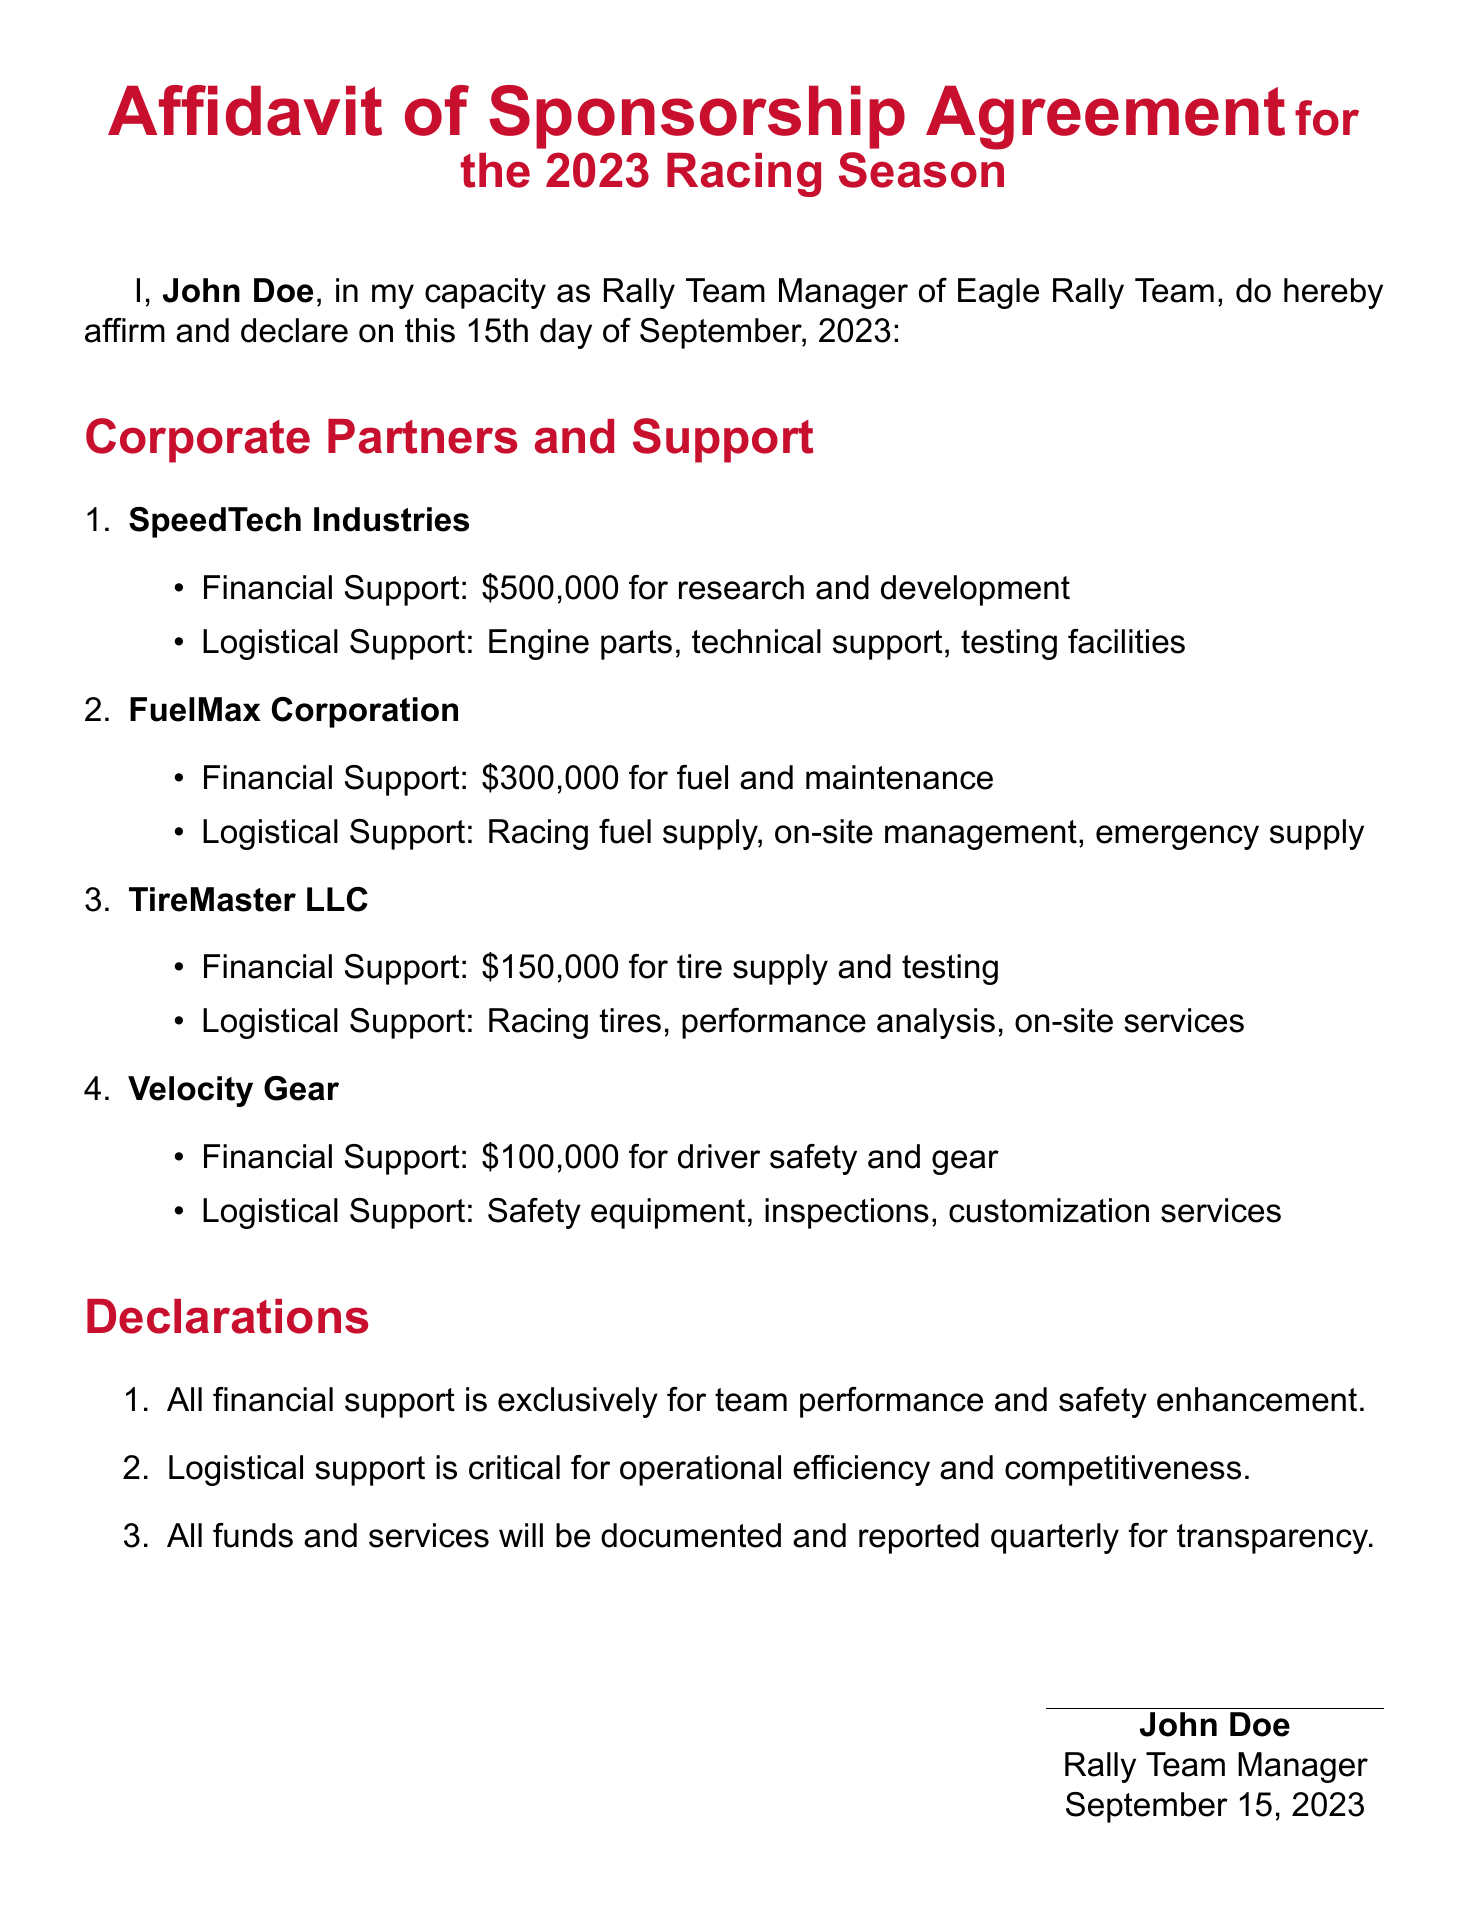What is the name of the Rally Team Manager? The document states the name of the Rally Team Manager as John Doe.
Answer: John Doe What date was the affidavit signed? The affidavit was signed on September 15, 2023, as indicated in the document.
Answer: September 15, 2023 How much financial support does SpeedTech Industries provide? The document specifies that SpeedTech Industries provides financial support of $500,000.
Answer: $500,000 What type of support does TireMaster LLC provide? TireMaster LLC provides racing tires and performance analysis as logistical support.
Answer: Racing tires, performance analysis How many corporate partners are listed in the affidavit? The document enumerates four corporate partners involved in the sponsorship agreement.
Answer: Four What is the total financial support provided by FuelMax Corporation? FuelMax Corporation's financial support is explicitly stated as $300,000 in the document.
Answer: $300,000 Why is logistical support deemed critical in the affidavit? The affidavit states logistical support is essential for operational efficiency and competitiveness.
Answer: Operational efficiency and competitiveness What type of document is this? The document is an Affidavit of Sponsorship Agreement for the 2023 Racing Season.
Answer: Affidavit of Sponsorship Agreement 